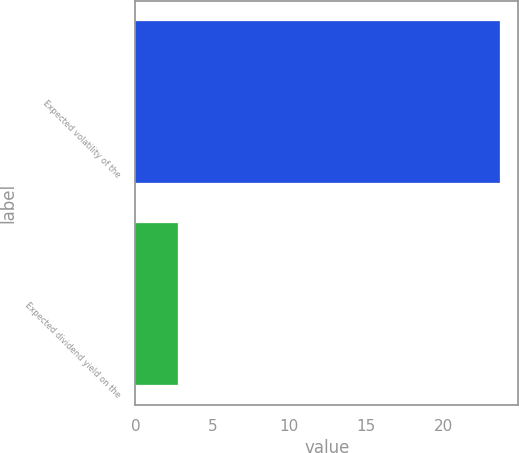Convert chart. <chart><loc_0><loc_0><loc_500><loc_500><bar_chart><fcel>Expected volatility of the<fcel>Expected dividend yield on the<nl><fcel>23.7<fcel>2.78<nl></chart> 